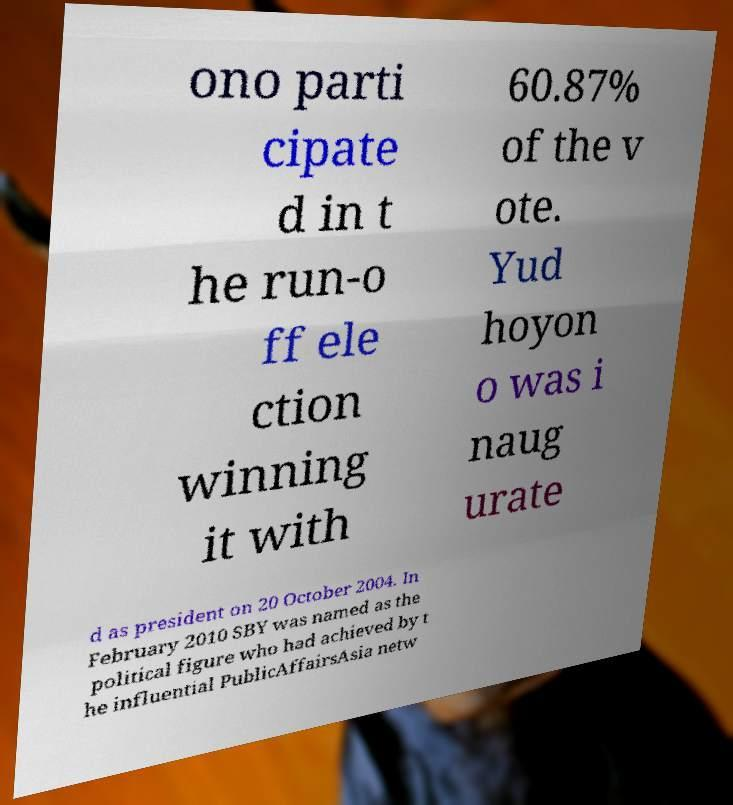Can you read and provide the text displayed in the image?This photo seems to have some interesting text. Can you extract and type it out for me? ono parti cipate d in t he run-o ff ele ction winning it with 60.87% of the v ote. Yud hoyon o was i naug urate d as president on 20 October 2004. In February 2010 SBY was named as the political figure who had achieved by t he influential PublicAffairsAsia netw 